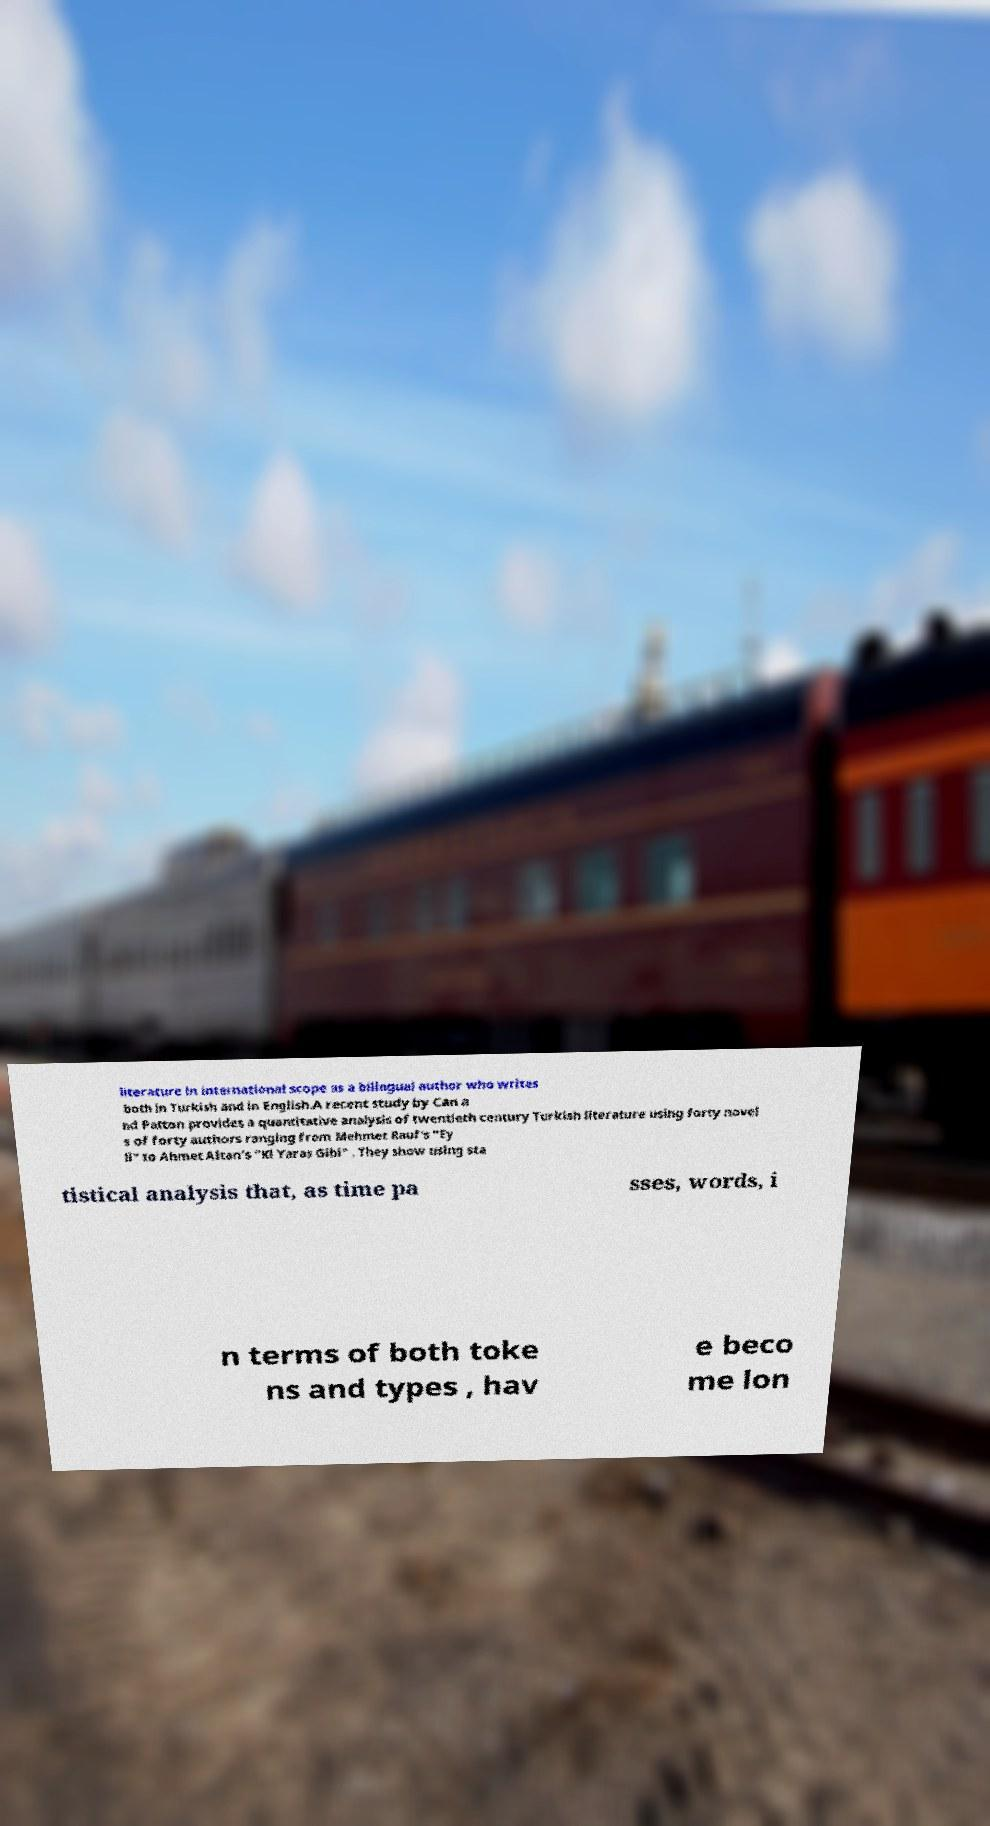I need the written content from this picture converted into text. Can you do that? literature in international scope as a bilingual author who writes both in Turkish and in English.A recent study by Can a nd Patton provides a quantitative analysis of twentieth century Turkish literature using forty novel s of forty authors ranging from Mehmet Rauf's "Ey ll" to Ahmet Altan's "Kl Yaras Gibi" . They show using sta tistical analysis that, as time pa sses, words, i n terms of both toke ns and types , hav e beco me lon 